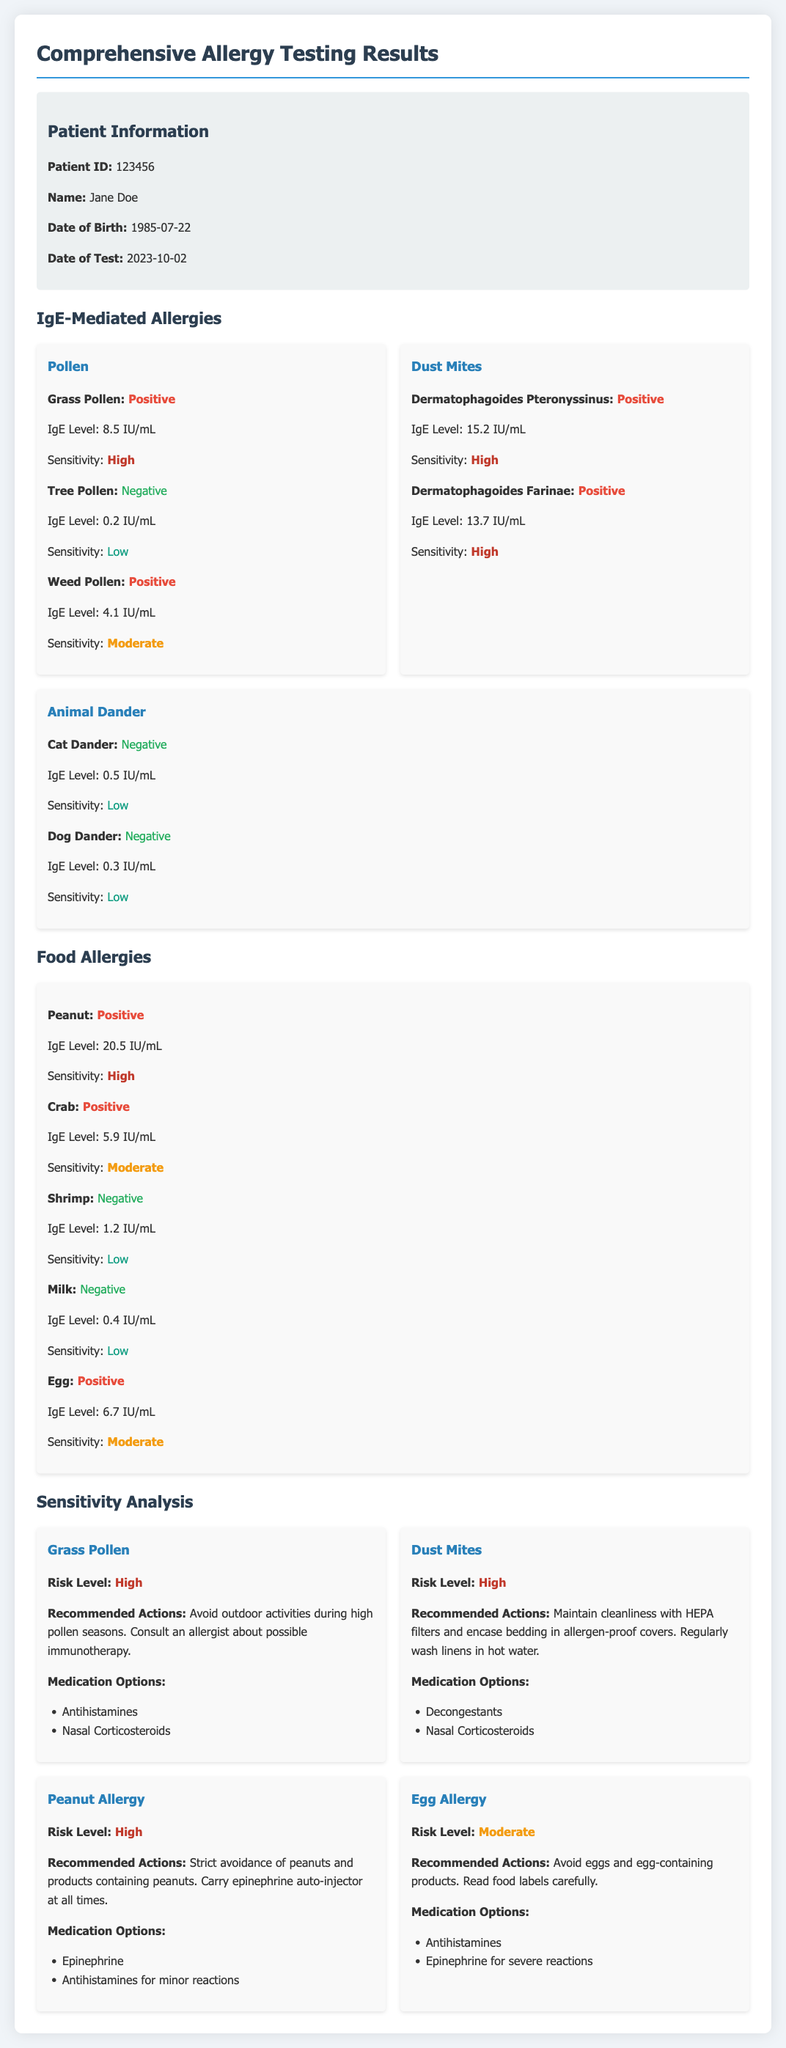What is the Patient ID? The Patient ID is found in the Patient Information section.
Answer: 123456 What is the IgE Level for Peanut? The IgE Level for Peanut is specified in the Food Allergies section.
Answer: 20.5 IU/mL What is the sensitivity level for Dermatophagoides Pteronyssinus? The sensitivity level is listed under the Dust Mites category in IgE-Mediated Allergies.
Answer: High Which medication is recommended for Egg Allergy? The recommended medication is mentioned in the Sensitivity Analysis section for Egg Allergy.
Answer: Antihistamines What date was the test conducted? The date of the test is provided in the Patient Information section.
Answer: 2023-10-02 How many positive tests are there for Pollen? The count of positive tests is determined by evaluating the Pollen category in IgE-Mediated Allergies.
Answer: 2 What is the risk level for Dust Mites? The risk level is detailed in the Sensitivity Analysis section specific to Dust Mites.
Answer: High What action is recommended for Grass Pollen? The recommended action is provided in the Sensitivity Analysis section for Grass Pollen.
Answer: Avoid outdoor activities during high pollen seasons 